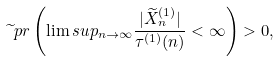Convert formula to latex. <formula><loc_0><loc_0><loc_500><loc_500>\widetilde { \ } p r \left ( \lim s u p _ { n \to \infty } \frac { | \widetilde { X } ^ { ( 1 ) } _ { n } | } { \tau ^ { ( 1 ) } ( n ) } < \infty \right ) > 0 ,</formula> 